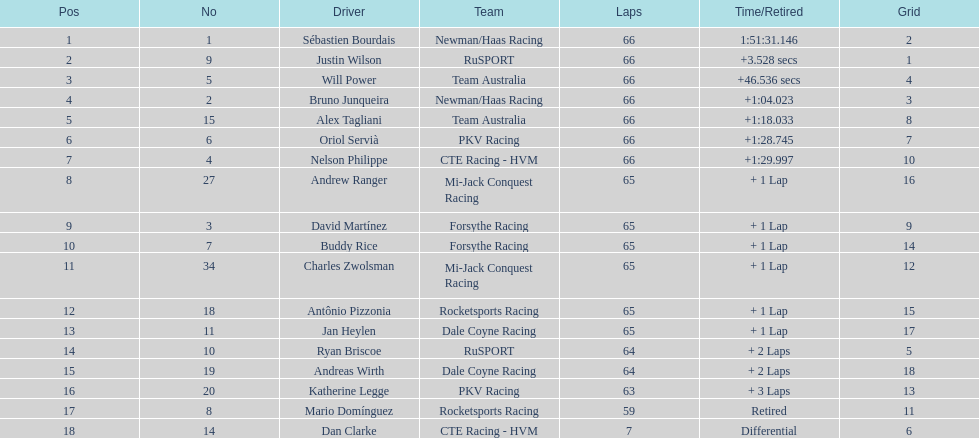Who are all of the 2006 gran premio telmex drivers? Sébastien Bourdais, Justin Wilson, Will Power, Bruno Junqueira, Alex Tagliani, Oriol Servià, Nelson Philippe, Andrew Ranger, David Martínez, Buddy Rice, Charles Zwolsman, Antônio Pizzonia, Jan Heylen, Ryan Briscoe, Andreas Wirth, Katherine Legge, Mario Domínguez, Dan Clarke. How many laps did they finish? 66, 66, 66, 66, 66, 66, 66, 65, 65, 65, 65, 65, 65, 64, 64, 63, 59, 7. What about just oriol servia and katherine legge? 66, 63. And which of those two drivers finished more laps? Oriol Servià. 